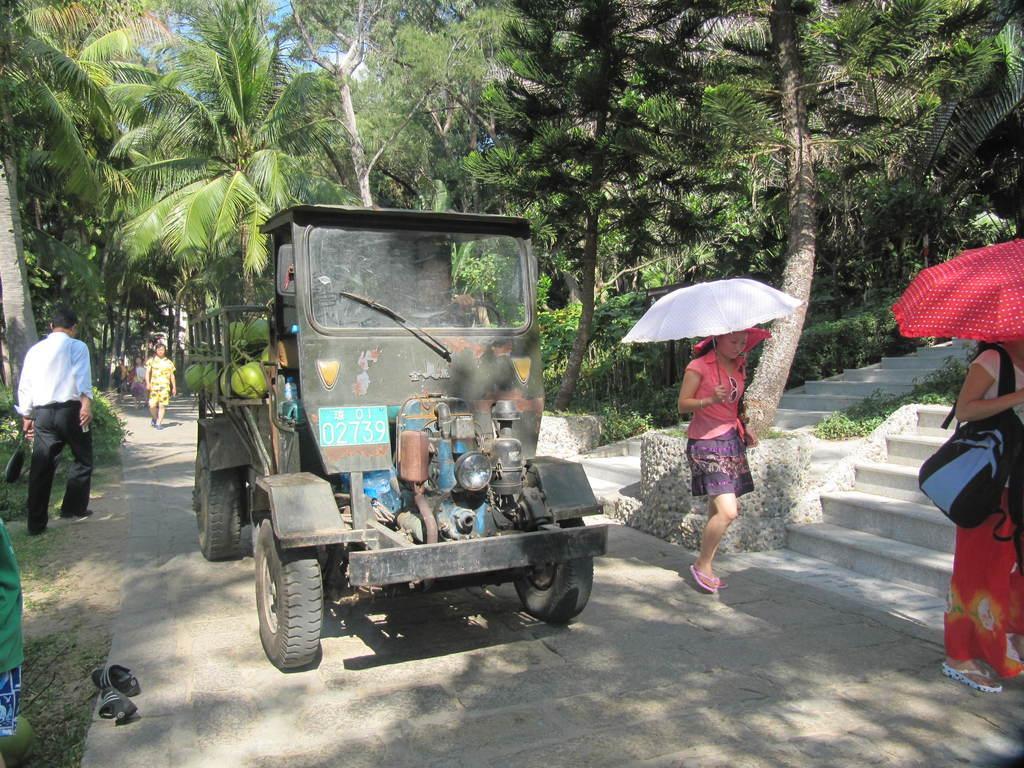Please provide a concise description of this image. In this picture we can see a vehicle here, on the right side there are two women holding umbrellas, in the background there are some trees here, we can see stairs here, on the left side there is a person walking here. 